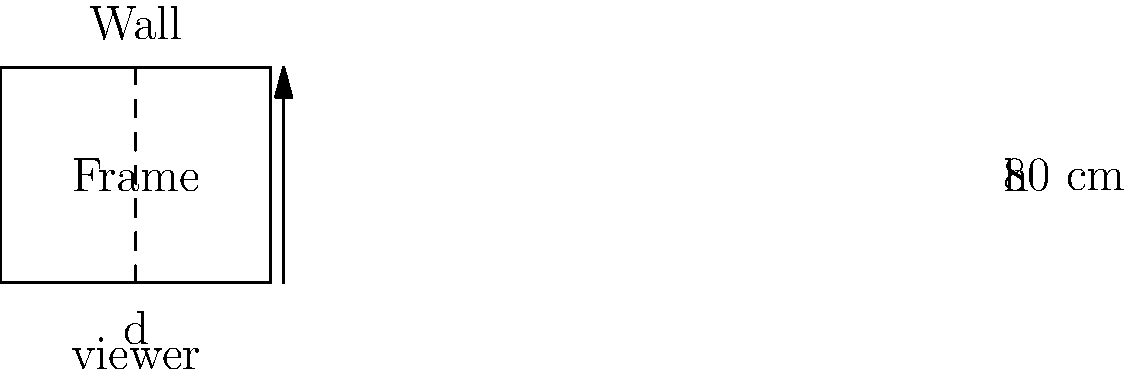A framed artwork is hung on a wall, with the center of the frame at eye level. The frame is 80 cm tall, and you want to determine the optimal viewing distance for appreciating the artwork. According to the "rule of 2.5," the ideal viewing distance is 2.5 times the height of the frame. However, you're skeptical and want to verify if this distance allows you to view the entire frame within a 45-degree vertical field of view. What is the minimum viewing distance, in centimeters, that satisfies both the "rule of 2.5" and the 45-degree field of view criterion? Let's approach this step-by-step:

1) First, calculate the viewing distance according to the "rule of 2.5":
   $d_{rule} = 2.5 \times 80 \text{ cm} = 200 \text{ cm}$

2) Now, let's consider the 45-degree field of view criterion. This means that the angle between the top and bottom of the frame should be 45° or less.

3) We can split this angle into two right triangles, each with a 22.5° angle (half of 45°).

4) In this right triangle:
   - The opposite side is half the height of the frame: $40 \text{ cm}$
   - The adjacent side is the viewing distance we're looking for: $d$

5) We can use the tangent function:
   $\tan(22.5°) = \frac{\text{opposite}}{\text{adjacent}} = \frac{40}{d}$

6) Solving for $d$:
   $d = \frac{40}{\tan(22.5°)} \approx 96.8 \text{ cm}$

7) The minimum viewing distance that satisfies both criteria is the larger of these two values:
   $\max(200 \text{ cm}, 96.8 \text{ cm}) = 200 \text{ cm}$

Therefore, the viewing distance of 200 cm satisfies both the "rule of 2.5" and the 45-degree field of view criterion.
Answer: 200 cm 